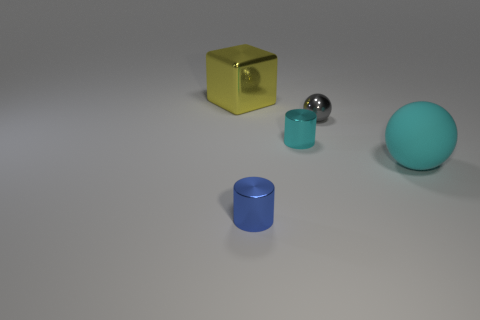Is there any other thing that is the same material as the cyan ball?
Give a very brief answer. No. There is a thing that is both in front of the cyan metallic cylinder and to the right of the blue thing; what is its material?
Give a very brief answer. Rubber. What color is the metal cube?
Keep it short and to the point. Yellow. How many tiny blue shiny things are the same shape as the small cyan shiny thing?
Your answer should be compact. 1. Do the thing left of the small blue object and the tiny cylinder that is behind the large cyan sphere have the same material?
Provide a short and direct response. Yes. There is a cyan object left of the metallic object that is to the right of the small cyan shiny object; what is its size?
Make the answer very short. Small. What is the material of the large object that is the same shape as the small gray thing?
Provide a short and direct response. Rubber. Do the cyan metallic thing that is to the left of the gray ball and the metallic object that is in front of the big cyan rubber thing have the same shape?
Give a very brief answer. Yes. Are there more blue metallic objects than metal things?
Give a very brief answer. No. The yellow metal block is what size?
Offer a very short reply. Large. 